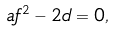<formula> <loc_0><loc_0><loc_500><loc_500>a f ^ { 2 } - 2 d = 0 ,</formula> 